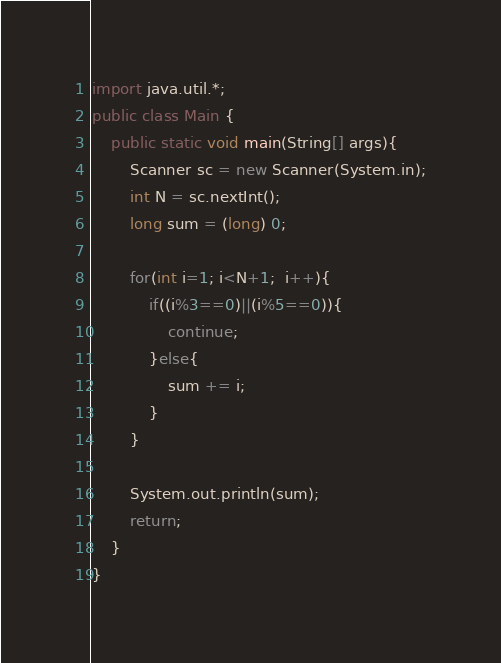Convert code to text. <code><loc_0><loc_0><loc_500><loc_500><_Java_>import java.util.*;
public class Main {
	public static void main(String[] args){
		Scanner sc = new Scanner(System.in);
      	int N = sc.nextInt();
      	long sum = (long) 0;

      	for(int i=1; i<N+1;  i++){
			if((i%3==0)||(i%5==0)){
              	continue;
            }else{
            	sum += i;
            }
        }
      
      	System.out.println(sum);
        return;
	}
}
</code> 